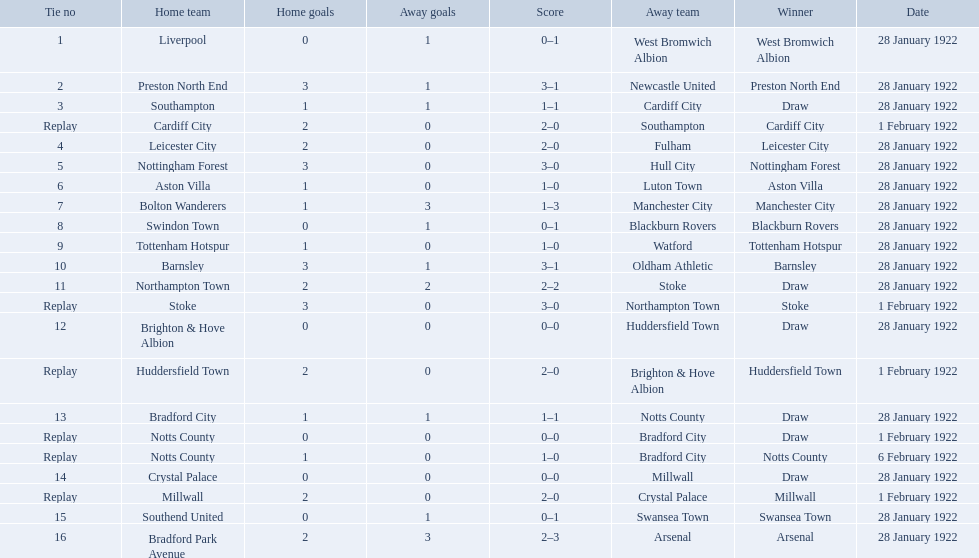Which team had a score of 0-1? Liverpool. Which team had a replay? Cardiff City. Which team had the same score as aston villa? Tottenham Hotspur. 